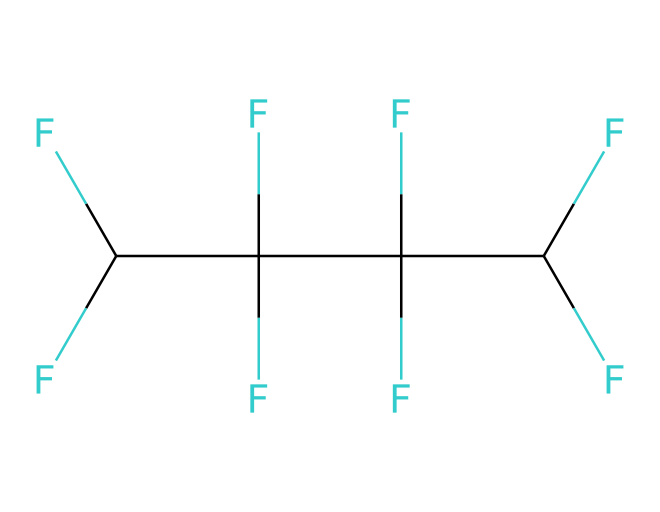What is the basic structural unit of this fluoropolymer? The chemical consists of a carbon backbone with fluorine atoms substituting hydrogen atoms. Each carbon is bonded to three fluorine atoms, indicating a perfluorinated structure.
Answer: carbon backbone How many carbon atoms are in the structure? By analyzing the SMILES representation, we can count four carbon atoms, as indicated by the number of "C" symbols.
Answer: four What is the degree of fluorination in this polymer? The structure indicates that all hydrogen atoms are replaced by fluorine atoms. Each carbon is bonded to three fluorine atoms, showing complete fluorination.
Answer: complete What physical property might this fluoropolymer exhibit due to its structure? The presence of fluorine atoms contributes to a high degree of chemical resistance and low surface energy, leading to water repellency and weather resistance.
Answer: weather resistance How many substituents are there attached to each carbon? Each carbon atom in this structure is bonded to three fluorine atoms, indicating there are three substituents per carbon atom.
Answer: three What type of chemical bonding is primarily involved in this structure? The structure shows covalent bonding between carbon and fluorine atoms, which is typical for polymers, providing strength and durability.
Answer: covalent bonding 